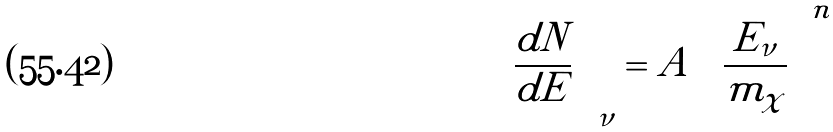Convert formula to latex. <formula><loc_0><loc_0><loc_500><loc_500>\left ( \frac { d N } { d E } \right ) _ { \nu } = A \left ( \frac { E _ { \nu } } { m _ { \chi } } \right ) ^ { n }</formula> 